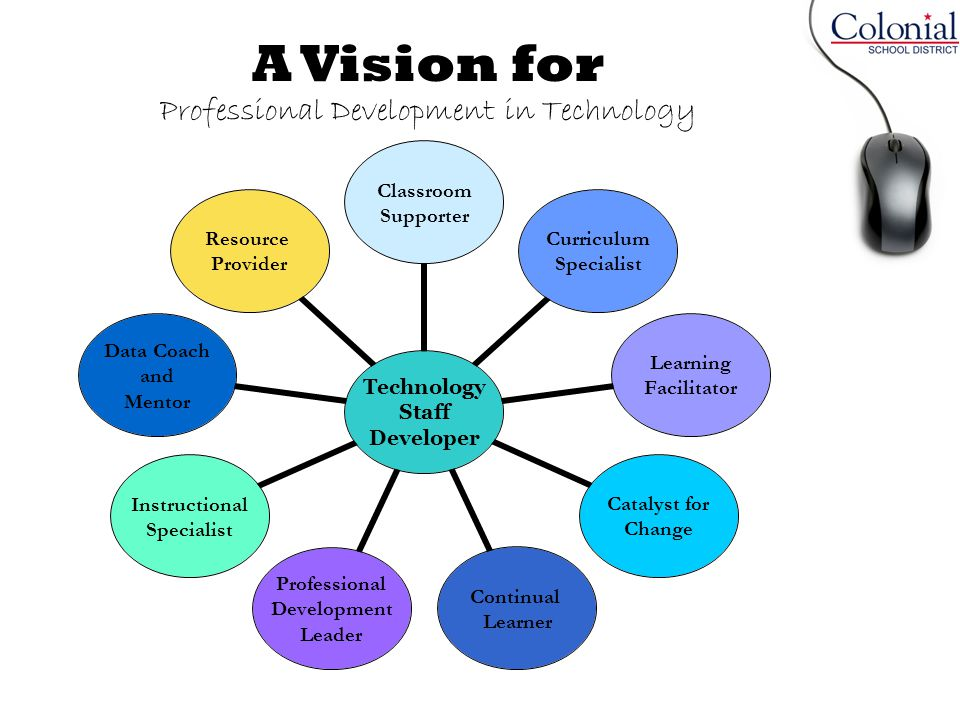Imagine a future scenario where technology has drastically advanced. How might the role of 'Technology Staff Developer' evolve in such a scenario? In a future scenario where technology has drastically advanced, the role of the 'Technology Staff Developer' might evolve to include responsibilities such as overseeing the integration of artificial intelligence and machine learning into the educational framework, ensuring that educators are equipped with the skills to utilize these advanced technologies. They might also be involved in the development of virtual and augmented reality learning environments, providing immersive educational experiences that were previously unimaginable. Additionally, they could act as consultants for personalized learning pathways powered by big data analytics, helping to tailor education to the unique needs and abilities of each student. Another key aspect of their role could be to ensure the ethical use of technology in education, addressing concerns such as data privacy and security, and promoting digital citizenship among both staff and students. 